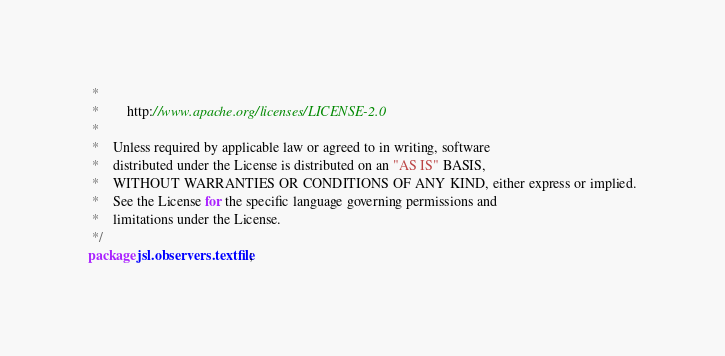<code> <loc_0><loc_0><loc_500><loc_500><_Java_> *
 *        http://www.apache.org/licenses/LICENSE-2.0
 *
 *    Unless required by applicable law or agreed to in writing, software
 *    distributed under the License is distributed on an "AS IS" BASIS,
 *    WITHOUT WARRANTIES OR CONDITIONS OF ANY KIND, either express or implied.
 *    See the License for the specific language governing permissions and
 *    limitations under the License.
 */
package jsl.observers.textfile;
</code> 